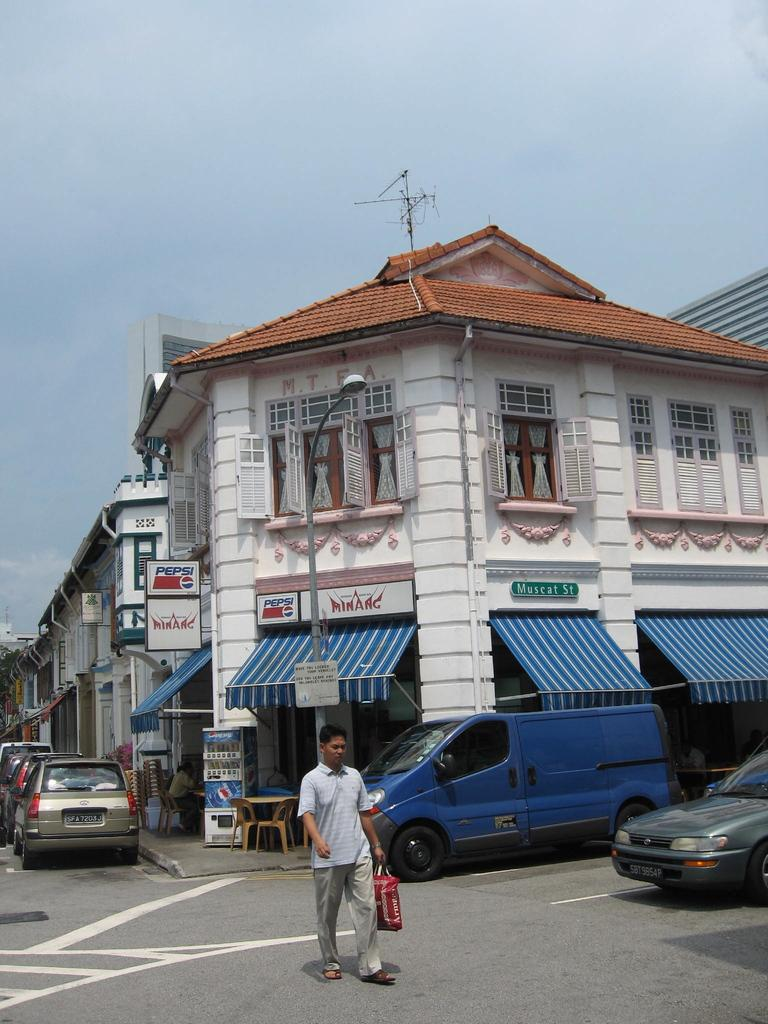What is the main subject of the image? There is a person in the image. What is the person holding? The person is holding a bag. Where is the person located? The person is walking on the street. What can be seen in the background of the image? There are name boards, buildings, a pole, lights, an antenna, and vehicles in the image. What is visible in the sky? The sky is visible in the image. What type of country is depicted in the image? The image does not depict a country; it shows a person walking on the street with various background elements. Can you tell me how many baths are visible in the image? There are no baths present in the image. 